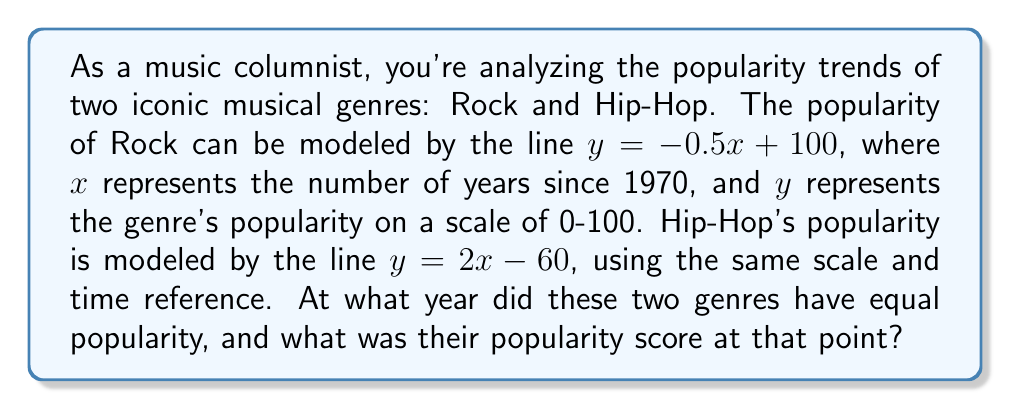Can you answer this question? To solve this problem, we need to find the intersection point of the two lines representing the popularity trends of Rock and Hip-Hop. Let's approach this step-by-step:

1) The equations of the two lines are:
   Rock: $y = -0.5x + 100$
   Hip-Hop: $y = 2x - 60$

2) At the intersection point, the $y$ values (popularity scores) will be equal. So we can set the equations equal to each other:
   $-0.5x + 100 = 2x - 60$

3) Now, let's solve this equation for $x$:
   $-0.5x + 100 = 2x - 60$
   $100 + 60 = 2x + 0.5x$
   $160 = 2.5x$
   $x = 160 / 2.5 = 64$

4) This means the genres had equal popularity 64 years after 1970, which is in the year 2034.

5) To find the popularity score at this point, we can substitute $x = 64$ into either of the original equations. Let's use the Rock equation:
   $y = -0.5(64) + 100$
   $y = -32 + 100 = 68$

Therefore, the two genres will have equal popularity in 2034, with a popularity score of 68.

[asy]
import graph;
size(200,200);
real f(real x) {return -0.5x + 100;}
real g(real x) {return 2x - 60;}
draw(graph(f,0,100), blue, "Rock");
draw(graph(g,0,100), red, "Hip-Hop");
dot((64,68), green);
label("(64, 68)", (64,68), NE);
xaxis("Years since 1970", arrow=Arrow);
yaxis("Popularity", arrow=Arrow);
[/asy]
Answer: The two genres will have equal popularity in 2034 (64 years after 1970), with a popularity score of 68. 